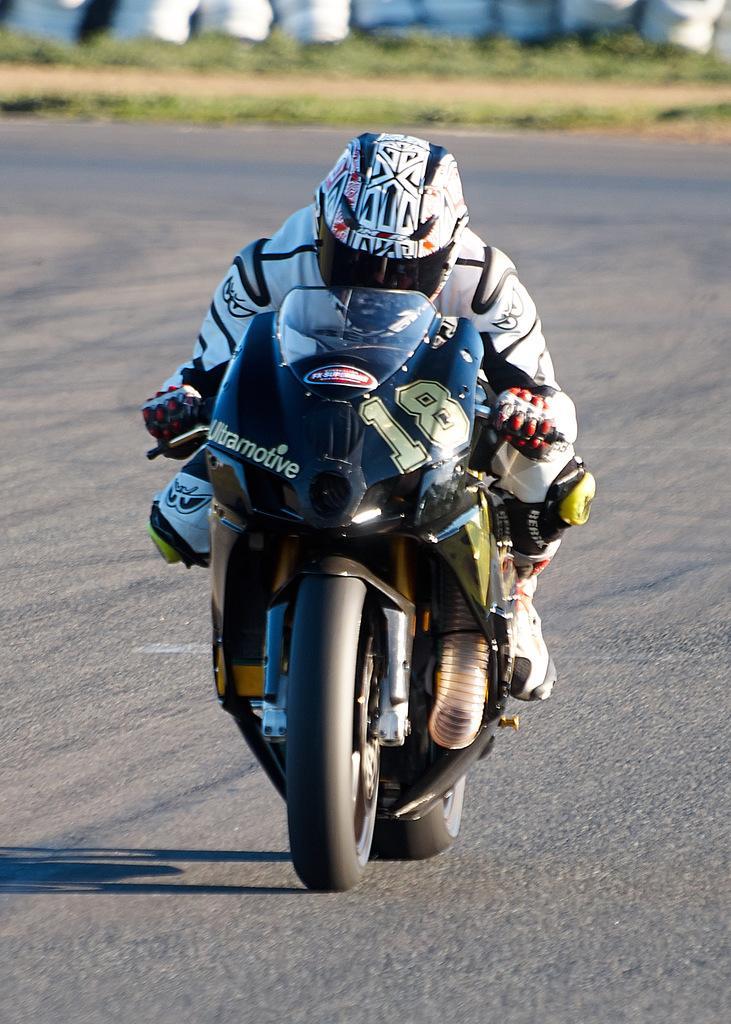Could you give a brief overview of what you see in this image? This picture is taken on the wide road and it is sunny. In this image, in the middle, we can see a man riding on the bike on the road. In the background, we can see white color, some plants and grass. In the background, we can see a road which is in black color. 